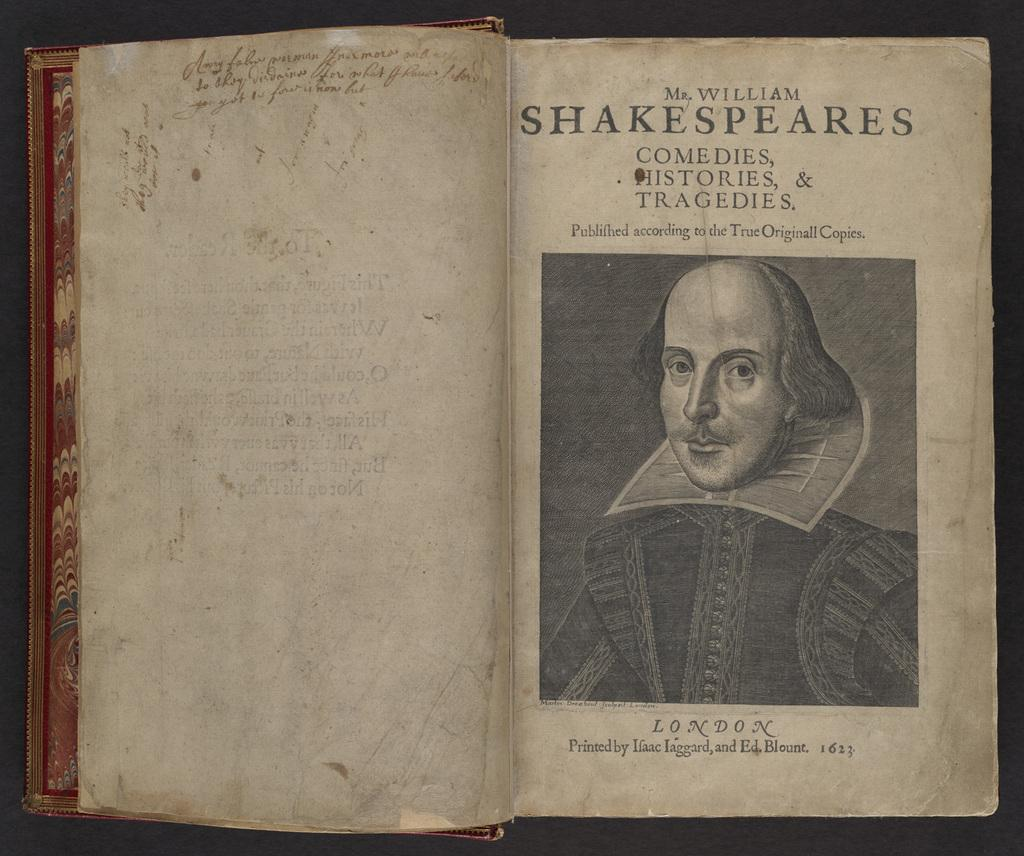What object is present in the image? There is a book in the image. What is depicted on the book? There is a man depicted on the book. What else can be seen in relation to the book? There is text associated with the book. How does the book contribute to reducing pollution in the image? The image does not show any information about pollution, and the book's presence does not imply any action related to pollution reduction. 